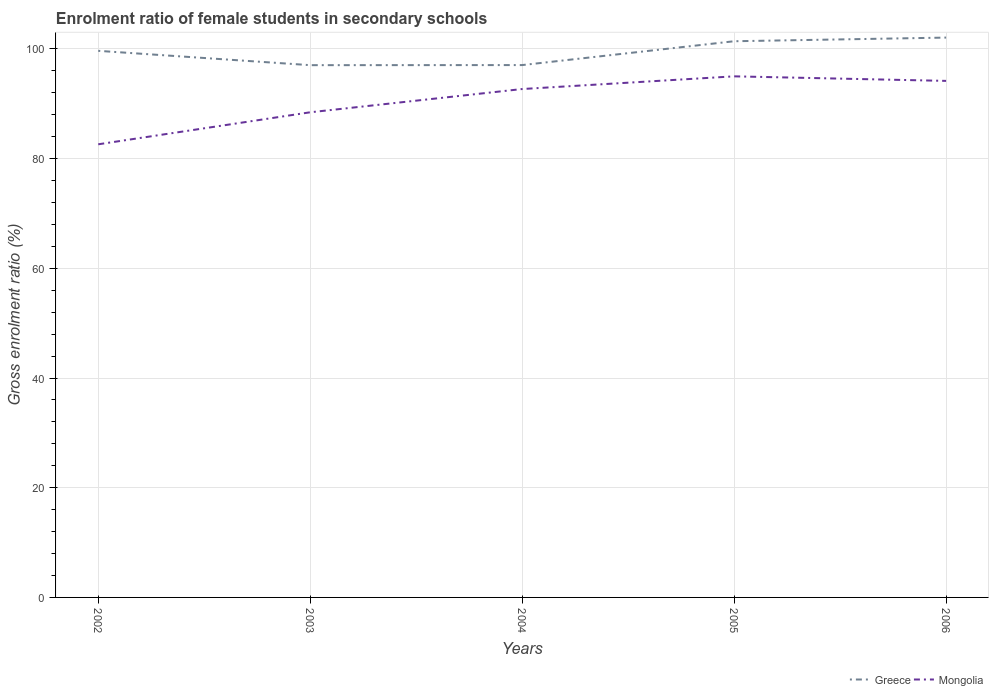Does the line corresponding to Greece intersect with the line corresponding to Mongolia?
Keep it short and to the point. No. Is the number of lines equal to the number of legend labels?
Ensure brevity in your answer.  Yes. Across all years, what is the maximum enrolment ratio of female students in secondary schools in Greece?
Your answer should be very brief. 97.05. In which year was the enrolment ratio of female students in secondary schools in Mongolia maximum?
Provide a succinct answer. 2002. What is the total enrolment ratio of female students in secondary schools in Greece in the graph?
Keep it short and to the point. -4.35. What is the difference between the highest and the second highest enrolment ratio of female students in secondary schools in Mongolia?
Your answer should be compact. 12.39. How many lines are there?
Offer a very short reply. 2. What is the difference between two consecutive major ticks on the Y-axis?
Provide a short and direct response. 20. Are the values on the major ticks of Y-axis written in scientific E-notation?
Your response must be concise. No. Does the graph contain any zero values?
Provide a succinct answer. No. Where does the legend appear in the graph?
Ensure brevity in your answer.  Bottom right. How many legend labels are there?
Offer a terse response. 2. How are the legend labels stacked?
Give a very brief answer. Horizontal. What is the title of the graph?
Give a very brief answer. Enrolment ratio of female students in secondary schools. Does "Ecuador" appear as one of the legend labels in the graph?
Provide a short and direct response. No. What is the Gross enrolment ratio (%) in Greece in 2002?
Keep it short and to the point. 99.66. What is the Gross enrolment ratio (%) of Mongolia in 2002?
Your answer should be very brief. 82.62. What is the Gross enrolment ratio (%) of Greece in 2003?
Your answer should be compact. 97.05. What is the Gross enrolment ratio (%) of Mongolia in 2003?
Your answer should be compact. 88.46. What is the Gross enrolment ratio (%) of Greece in 2004?
Make the answer very short. 97.06. What is the Gross enrolment ratio (%) in Mongolia in 2004?
Your answer should be compact. 92.7. What is the Gross enrolment ratio (%) in Greece in 2005?
Make the answer very short. 101.41. What is the Gross enrolment ratio (%) of Mongolia in 2005?
Provide a short and direct response. 95.01. What is the Gross enrolment ratio (%) in Greece in 2006?
Give a very brief answer. 102.08. What is the Gross enrolment ratio (%) in Mongolia in 2006?
Ensure brevity in your answer.  94.18. Across all years, what is the maximum Gross enrolment ratio (%) in Greece?
Your response must be concise. 102.08. Across all years, what is the maximum Gross enrolment ratio (%) of Mongolia?
Offer a very short reply. 95.01. Across all years, what is the minimum Gross enrolment ratio (%) of Greece?
Keep it short and to the point. 97.05. Across all years, what is the minimum Gross enrolment ratio (%) in Mongolia?
Give a very brief answer. 82.62. What is the total Gross enrolment ratio (%) of Greece in the graph?
Give a very brief answer. 497.26. What is the total Gross enrolment ratio (%) in Mongolia in the graph?
Give a very brief answer. 452.97. What is the difference between the Gross enrolment ratio (%) of Greece in 2002 and that in 2003?
Offer a terse response. 2.61. What is the difference between the Gross enrolment ratio (%) of Mongolia in 2002 and that in 2003?
Offer a very short reply. -5.84. What is the difference between the Gross enrolment ratio (%) of Greece in 2002 and that in 2004?
Give a very brief answer. 2.6. What is the difference between the Gross enrolment ratio (%) in Mongolia in 2002 and that in 2004?
Provide a short and direct response. -10.08. What is the difference between the Gross enrolment ratio (%) of Greece in 2002 and that in 2005?
Your answer should be compact. -1.75. What is the difference between the Gross enrolment ratio (%) of Mongolia in 2002 and that in 2005?
Provide a short and direct response. -12.39. What is the difference between the Gross enrolment ratio (%) of Greece in 2002 and that in 2006?
Offer a very short reply. -2.41. What is the difference between the Gross enrolment ratio (%) in Mongolia in 2002 and that in 2006?
Ensure brevity in your answer.  -11.56. What is the difference between the Gross enrolment ratio (%) of Greece in 2003 and that in 2004?
Make the answer very short. -0.02. What is the difference between the Gross enrolment ratio (%) in Mongolia in 2003 and that in 2004?
Your answer should be very brief. -4.24. What is the difference between the Gross enrolment ratio (%) in Greece in 2003 and that in 2005?
Offer a very short reply. -4.36. What is the difference between the Gross enrolment ratio (%) in Mongolia in 2003 and that in 2005?
Your answer should be very brief. -6.55. What is the difference between the Gross enrolment ratio (%) of Greece in 2003 and that in 2006?
Provide a succinct answer. -5.03. What is the difference between the Gross enrolment ratio (%) in Mongolia in 2003 and that in 2006?
Provide a succinct answer. -5.72. What is the difference between the Gross enrolment ratio (%) in Greece in 2004 and that in 2005?
Give a very brief answer. -4.35. What is the difference between the Gross enrolment ratio (%) in Mongolia in 2004 and that in 2005?
Offer a terse response. -2.31. What is the difference between the Gross enrolment ratio (%) in Greece in 2004 and that in 2006?
Your answer should be very brief. -5.01. What is the difference between the Gross enrolment ratio (%) in Mongolia in 2004 and that in 2006?
Keep it short and to the point. -1.48. What is the difference between the Gross enrolment ratio (%) in Greece in 2005 and that in 2006?
Your response must be concise. -0.67. What is the difference between the Gross enrolment ratio (%) in Mongolia in 2005 and that in 2006?
Ensure brevity in your answer.  0.83. What is the difference between the Gross enrolment ratio (%) of Greece in 2002 and the Gross enrolment ratio (%) of Mongolia in 2003?
Offer a very short reply. 11.21. What is the difference between the Gross enrolment ratio (%) of Greece in 2002 and the Gross enrolment ratio (%) of Mongolia in 2004?
Provide a succinct answer. 6.96. What is the difference between the Gross enrolment ratio (%) in Greece in 2002 and the Gross enrolment ratio (%) in Mongolia in 2005?
Your answer should be very brief. 4.65. What is the difference between the Gross enrolment ratio (%) in Greece in 2002 and the Gross enrolment ratio (%) in Mongolia in 2006?
Your answer should be very brief. 5.48. What is the difference between the Gross enrolment ratio (%) of Greece in 2003 and the Gross enrolment ratio (%) of Mongolia in 2004?
Your answer should be compact. 4.35. What is the difference between the Gross enrolment ratio (%) of Greece in 2003 and the Gross enrolment ratio (%) of Mongolia in 2005?
Offer a very short reply. 2.04. What is the difference between the Gross enrolment ratio (%) of Greece in 2003 and the Gross enrolment ratio (%) of Mongolia in 2006?
Make the answer very short. 2.87. What is the difference between the Gross enrolment ratio (%) of Greece in 2004 and the Gross enrolment ratio (%) of Mongolia in 2005?
Give a very brief answer. 2.05. What is the difference between the Gross enrolment ratio (%) of Greece in 2004 and the Gross enrolment ratio (%) of Mongolia in 2006?
Keep it short and to the point. 2.88. What is the difference between the Gross enrolment ratio (%) in Greece in 2005 and the Gross enrolment ratio (%) in Mongolia in 2006?
Offer a terse response. 7.23. What is the average Gross enrolment ratio (%) of Greece per year?
Provide a succinct answer. 99.45. What is the average Gross enrolment ratio (%) of Mongolia per year?
Make the answer very short. 90.59. In the year 2002, what is the difference between the Gross enrolment ratio (%) in Greece and Gross enrolment ratio (%) in Mongolia?
Provide a succinct answer. 17.04. In the year 2003, what is the difference between the Gross enrolment ratio (%) of Greece and Gross enrolment ratio (%) of Mongolia?
Give a very brief answer. 8.59. In the year 2004, what is the difference between the Gross enrolment ratio (%) in Greece and Gross enrolment ratio (%) in Mongolia?
Ensure brevity in your answer.  4.37. In the year 2005, what is the difference between the Gross enrolment ratio (%) of Greece and Gross enrolment ratio (%) of Mongolia?
Your answer should be compact. 6.4. In the year 2006, what is the difference between the Gross enrolment ratio (%) of Greece and Gross enrolment ratio (%) of Mongolia?
Ensure brevity in your answer.  7.9. What is the ratio of the Gross enrolment ratio (%) of Greece in 2002 to that in 2003?
Keep it short and to the point. 1.03. What is the ratio of the Gross enrolment ratio (%) in Mongolia in 2002 to that in 2003?
Your response must be concise. 0.93. What is the ratio of the Gross enrolment ratio (%) in Greece in 2002 to that in 2004?
Make the answer very short. 1.03. What is the ratio of the Gross enrolment ratio (%) of Mongolia in 2002 to that in 2004?
Give a very brief answer. 0.89. What is the ratio of the Gross enrolment ratio (%) in Greece in 2002 to that in 2005?
Make the answer very short. 0.98. What is the ratio of the Gross enrolment ratio (%) in Mongolia in 2002 to that in 2005?
Provide a short and direct response. 0.87. What is the ratio of the Gross enrolment ratio (%) in Greece in 2002 to that in 2006?
Provide a short and direct response. 0.98. What is the ratio of the Gross enrolment ratio (%) in Mongolia in 2002 to that in 2006?
Ensure brevity in your answer.  0.88. What is the ratio of the Gross enrolment ratio (%) in Greece in 2003 to that in 2004?
Ensure brevity in your answer.  1. What is the ratio of the Gross enrolment ratio (%) in Mongolia in 2003 to that in 2004?
Keep it short and to the point. 0.95. What is the ratio of the Gross enrolment ratio (%) in Greece in 2003 to that in 2005?
Your response must be concise. 0.96. What is the ratio of the Gross enrolment ratio (%) in Mongolia in 2003 to that in 2005?
Keep it short and to the point. 0.93. What is the ratio of the Gross enrolment ratio (%) in Greece in 2003 to that in 2006?
Make the answer very short. 0.95. What is the ratio of the Gross enrolment ratio (%) of Mongolia in 2003 to that in 2006?
Provide a short and direct response. 0.94. What is the ratio of the Gross enrolment ratio (%) in Greece in 2004 to that in 2005?
Keep it short and to the point. 0.96. What is the ratio of the Gross enrolment ratio (%) of Mongolia in 2004 to that in 2005?
Your answer should be very brief. 0.98. What is the ratio of the Gross enrolment ratio (%) in Greece in 2004 to that in 2006?
Ensure brevity in your answer.  0.95. What is the ratio of the Gross enrolment ratio (%) in Mongolia in 2004 to that in 2006?
Offer a very short reply. 0.98. What is the ratio of the Gross enrolment ratio (%) of Mongolia in 2005 to that in 2006?
Keep it short and to the point. 1.01. What is the difference between the highest and the second highest Gross enrolment ratio (%) in Greece?
Ensure brevity in your answer.  0.67. What is the difference between the highest and the second highest Gross enrolment ratio (%) in Mongolia?
Offer a terse response. 0.83. What is the difference between the highest and the lowest Gross enrolment ratio (%) in Greece?
Ensure brevity in your answer.  5.03. What is the difference between the highest and the lowest Gross enrolment ratio (%) in Mongolia?
Ensure brevity in your answer.  12.39. 